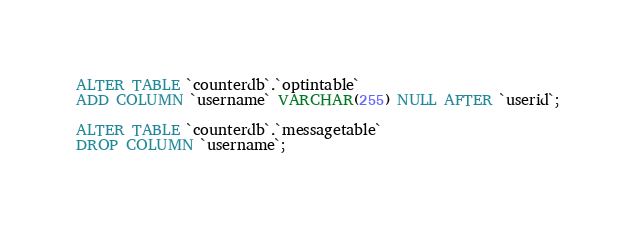<code> <loc_0><loc_0><loc_500><loc_500><_SQL_>ALTER TABLE `counterdb`.`optintable` 
ADD COLUMN `username` VARCHAR(255) NULL AFTER `userid`;

ALTER TABLE `counterdb`.`messagetable` 
DROP COLUMN `username`;

</code> 